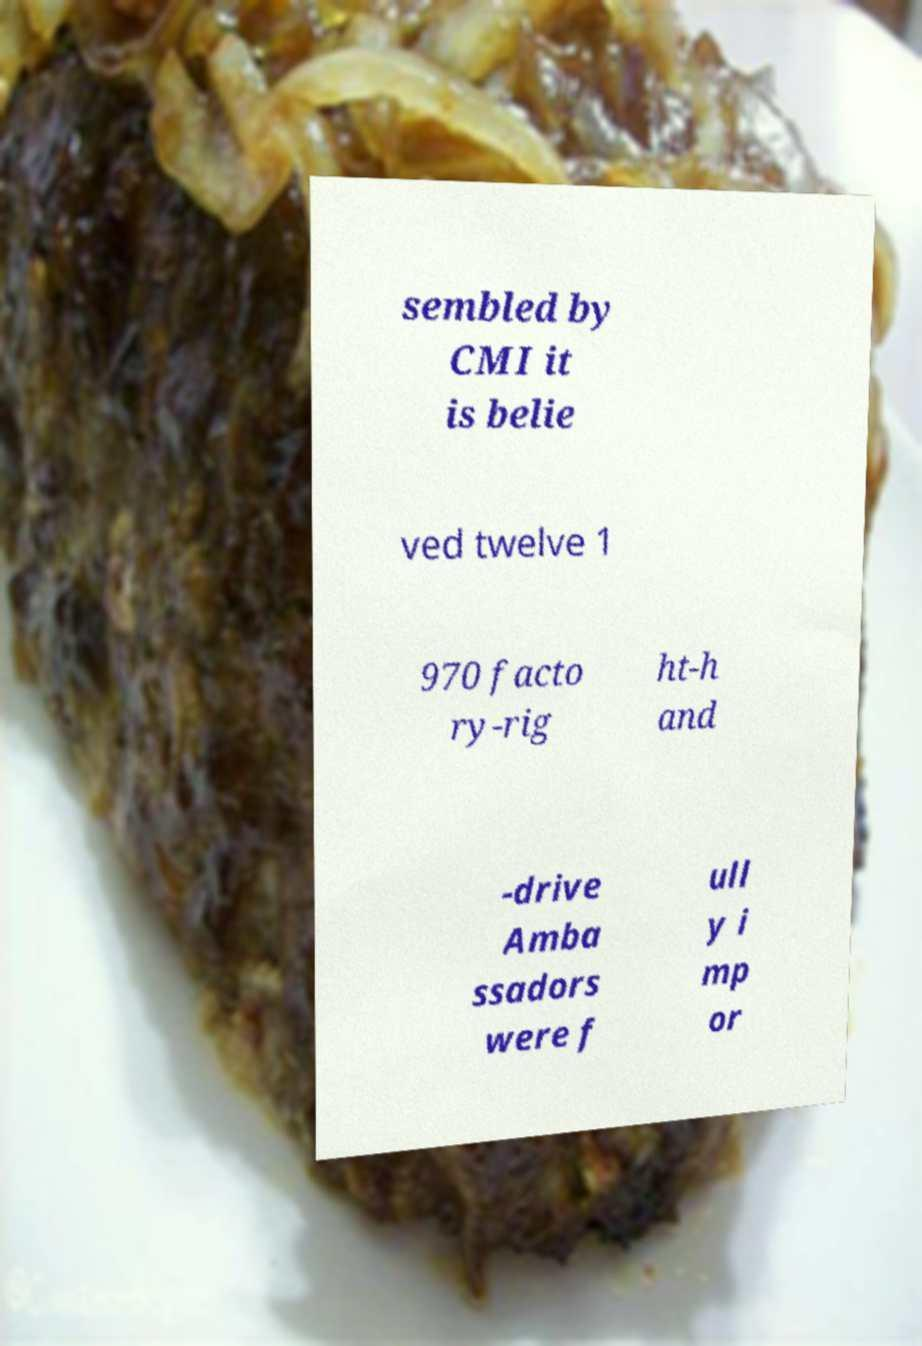Can you read and provide the text displayed in the image?This photo seems to have some interesting text. Can you extract and type it out for me? sembled by CMI it is belie ved twelve 1 970 facto ry-rig ht-h and -drive Amba ssadors were f ull y i mp or 